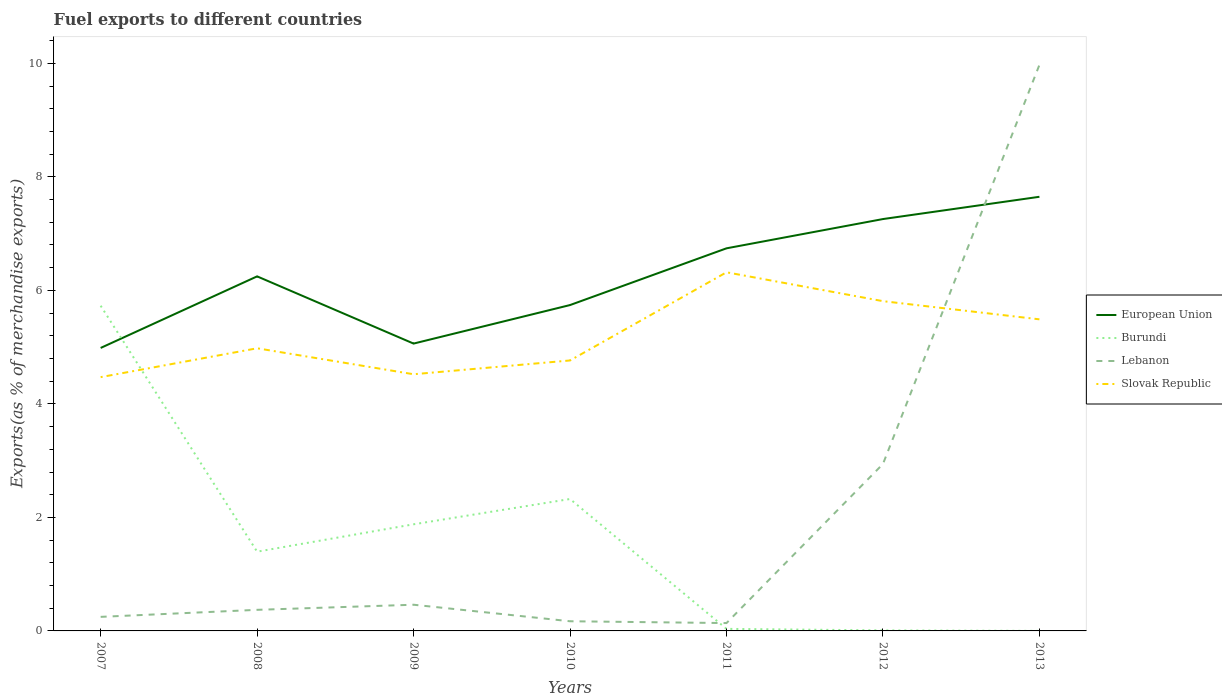Is the number of lines equal to the number of legend labels?
Give a very brief answer. Yes. Across all years, what is the maximum percentage of exports to different countries in Lebanon?
Ensure brevity in your answer.  0.14. What is the total percentage of exports to different countries in Slovak Republic in the graph?
Your answer should be compact. -1.34. What is the difference between the highest and the second highest percentage of exports to different countries in Lebanon?
Give a very brief answer. 9.84. Is the percentage of exports to different countries in Lebanon strictly greater than the percentage of exports to different countries in European Union over the years?
Offer a terse response. No. How many lines are there?
Ensure brevity in your answer.  4. What is the difference between two consecutive major ticks on the Y-axis?
Provide a short and direct response. 2. How are the legend labels stacked?
Offer a terse response. Vertical. What is the title of the graph?
Your response must be concise. Fuel exports to different countries. Does "Maldives" appear as one of the legend labels in the graph?
Keep it short and to the point. No. What is the label or title of the X-axis?
Make the answer very short. Years. What is the label or title of the Y-axis?
Ensure brevity in your answer.  Exports(as % of merchandise exports). What is the Exports(as % of merchandise exports) in European Union in 2007?
Ensure brevity in your answer.  4.99. What is the Exports(as % of merchandise exports) in Burundi in 2007?
Provide a short and direct response. 5.73. What is the Exports(as % of merchandise exports) of Lebanon in 2007?
Make the answer very short. 0.25. What is the Exports(as % of merchandise exports) in Slovak Republic in 2007?
Your answer should be compact. 4.47. What is the Exports(as % of merchandise exports) in European Union in 2008?
Make the answer very short. 6.25. What is the Exports(as % of merchandise exports) of Burundi in 2008?
Offer a terse response. 1.4. What is the Exports(as % of merchandise exports) of Lebanon in 2008?
Your answer should be very brief. 0.37. What is the Exports(as % of merchandise exports) of Slovak Republic in 2008?
Your answer should be compact. 4.98. What is the Exports(as % of merchandise exports) of European Union in 2009?
Your response must be concise. 5.06. What is the Exports(as % of merchandise exports) of Burundi in 2009?
Keep it short and to the point. 1.88. What is the Exports(as % of merchandise exports) in Lebanon in 2009?
Your response must be concise. 0.46. What is the Exports(as % of merchandise exports) in Slovak Republic in 2009?
Give a very brief answer. 4.52. What is the Exports(as % of merchandise exports) in European Union in 2010?
Make the answer very short. 5.74. What is the Exports(as % of merchandise exports) in Burundi in 2010?
Offer a very short reply. 2.32. What is the Exports(as % of merchandise exports) of Lebanon in 2010?
Your answer should be very brief. 0.17. What is the Exports(as % of merchandise exports) in Slovak Republic in 2010?
Provide a succinct answer. 4.77. What is the Exports(as % of merchandise exports) of European Union in 2011?
Provide a short and direct response. 6.74. What is the Exports(as % of merchandise exports) of Burundi in 2011?
Your answer should be very brief. 0.04. What is the Exports(as % of merchandise exports) in Lebanon in 2011?
Offer a very short reply. 0.14. What is the Exports(as % of merchandise exports) of Slovak Republic in 2011?
Offer a terse response. 6.32. What is the Exports(as % of merchandise exports) in European Union in 2012?
Provide a succinct answer. 7.26. What is the Exports(as % of merchandise exports) in Burundi in 2012?
Provide a succinct answer. 0.01. What is the Exports(as % of merchandise exports) in Lebanon in 2012?
Offer a terse response. 2.94. What is the Exports(as % of merchandise exports) in Slovak Republic in 2012?
Your answer should be very brief. 5.81. What is the Exports(as % of merchandise exports) of European Union in 2013?
Offer a very short reply. 7.65. What is the Exports(as % of merchandise exports) of Burundi in 2013?
Ensure brevity in your answer.  0. What is the Exports(as % of merchandise exports) of Lebanon in 2013?
Your answer should be very brief. 9.97. What is the Exports(as % of merchandise exports) in Slovak Republic in 2013?
Offer a terse response. 5.49. Across all years, what is the maximum Exports(as % of merchandise exports) of European Union?
Your answer should be compact. 7.65. Across all years, what is the maximum Exports(as % of merchandise exports) of Burundi?
Your answer should be compact. 5.73. Across all years, what is the maximum Exports(as % of merchandise exports) in Lebanon?
Give a very brief answer. 9.97. Across all years, what is the maximum Exports(as % of merchandise exports) in Slovak Republic?
Your response must be concise. 6.32. Across all years, what is the minimum Exports(as % of merchandise exports) in European Union?
Your answer should be compact. 4.99. Across all years, what is the minimum Exports(as % of merchandise exports) in Burundi?
Keep it short and to the point. 0. Across all years, what is the minimum Exports(as % of merchandise exports) in Lebanon?
Provide a succinct answer. 0.14. Across all years, what is the minimum Exports(as % of merchandise exports) of Slovak Republic?
Make the answer very short. 4.47. What is the total Exports(as % of merchandise exports) of European Union in the graph?
Make the answer very short. 43.68. What is the total Exports(as % of merchandise exports) in Burundi in the graph?
Ensure brevity in your answer.  11.38. What is the total Exports(as % of merchandise exports) in Lebanon in the graph?
Provide a succinct answer. 14.3. What is the total Exports(as % of merchandise exports) of Slovak Republic in the graph?
Keep it short and to the point. 36.36. What is the difference between the Exports(as % of merchandise exports) of European Union in 2007 and that in 2008?
Your response must be concise. -1.26. What is the difference between the Exports(as % of merchandise exports) of Burundi in 2007 and that in 2008?
Provide a short and direct response. 4.33. What is the difference between the Exports(as % of merchandise exports) in Lebanon in 2007 and that in 2008?
Your answer should be compact. -0.12. What is the difference between the Exports(as % of merchandise exports) of Slovak Republic in 2007 and that in 2008?
Ensure brevity in your answer.  -0.51. What is the difference between the Exports(as % of merchandise exports) in European Union in 2007 and that in 2009?
Your answer should be compact. -0.08. What is the difference between the Exports(as % of merchandise exports) of Burundi in 2007 and that in 2009?
Your answer should be compact. 3.85. What is the difference between the Exports(as % of merchandise exports) in Lebanon in 2007 and that in 2009?
Your answer should be compact. -0.21. What is the difference between the Exports(as % of merchandise exports) of Slovak Republic in 2007 and that in 2009?
Your answer should be very brief. -0.05. What is the difference between the Exports(as % of merchandise exports) in European Union in 2007 and that in 2010?
Make the answer very short. -0.76. What is the difference between the Exports(as % of merchandise exports) in Burundi in 2007 and that in 2010?
Ensure brevity in your answer.  3.41. What is the difference between the Exports(as % of merchandise exports) of Lebanon in 2007 and that in 2010?
Give a very brief answer. 0.08. What is the difference between the Exports(as % of merchandise exports) of Slovak Republic in 2007 and that in 2010?
Provide a succinct answer. -0.29. What is the difference between the Exports(as % of merchandise exports) in European Union in 2007 and that in 2011?
Ensure brevity in your answer.  -1.76. What is the difference between the Exports(as % of merchandise exports) of Burundi in 2007 and that in 2011?
Make the answer very short. 5.69. What is the difference between the Exports(as % of merchandise exports) of Lebanon in 2007 and that in 2011?
Give a very brief answer. 0.11. What is the difference between the Exports(as % of merchandise exports) of Slovak Republic in 2007 and that in 2011?
Make the answer very short. -1.85. What is the difference between the Exports(as % of merchandise exports) in European Union in 2007 and that in 2012?
Give a very brief answer. -2.27. What is the difference between the Exports(as % of merchandise exports) of Burundi in 2007 and that in 2012?
Your answer should be compact. 5.72. What is the difference between the Exports(as % of merchandise exports) of Lebanon in 2007 and that in 2012?
Keep it short and to the point. -2.69. What is the difference between the Exports(as % of merchandise exports) in Slovak Republic in 2007 and that in 2012?
Offer a very short reply. -1.34. What is the difference between the Exports(as % of merchandise exports) of European Union in 2007 and that in 2013?
Provide a succinct answer. -2.66. What is the difference between the Exports(as % of merchandise exports) of Burundi in 2007 and that in 2013?
Ensure brevity in your answer.  5.73. What is the difference between the Exports(as % of merchandise exports) of Lebanon in 2007 and that in 2013?
Give a very brief answer. -9.73. What is the difference between the Exports(as % of merchandise exports) of Slovak Republic in 2007 and that in 2013?
Keep it short and to the point. -1.02. What is the difference between the Exports(as % of merchandise exports) of European Union in 2008 and that in 2009?
Offer a terse response. 1.18. What is the difference between the Exports(as % of merchandise exports) in Burundi in 2008 and that in 2009?
Keep it short and to the point. -0.48. What is the difference between the Exports(as % of merchandise exports) of Lebanon in 2008 and that in 2009?
Keep it short and to the point. -0.09. What is the difference between the Exports(as % of merchandise exports) in Slovak Republic in 2008 and that in 2009?
Your answer should be very brief. 0.46. What is the difference between the Exports(as % of merchandise exports) of European Union in 2008 and that in 2010?
Keep it short and to the point. 0.51. What is the difference between the Exports(as % of merchandise exports) in Burundi in 2008 and that in 2010?
Give a very brief answer. -0.93. What is the difference between the Exports(as % of merchandise exports) in Lebanon in 2008 and that in 2010?
Keep it short and to the point. 0.2. What is the difference between the Exports(as % of merchandise exports) of Slovak Republic in 2008 and that in 2010?
Keep it short and to the point. 0.21. What is the difference between the Exports(as % of merchandise exports) of European Union in 2008 and that in 2011?
Offer a very short reply. -0.49. What is the difference between the Exports(as % of merchandise exports) of Burundi in 2008 and that in 2011?
Ensure brevity in your answer.  1.36. What is the difference between the Exports(as % of merchandise exports) of Lebanon in 2008 and that in 2011?
Ensure brevity in your answer.  0.23. What is the difference between the Exports(as % of merchandise exports) in Slovak Republic in 2008 and that in 2011?
Ensure brevity in your answer.  -1.34. What is the difference between the Exports(as % of merchandise exports) in European Union in 2008 and that in 2012?
Offer a terse response. -1.01. What is the difference between the Exports(as % of merchandise exports) in Burundi in 2008 and that in 2012?
Give a very brief answer. 1.39. What is the difference between the Exports(as % of merchandise exports) of Lebanon in 2008 and that in 2012?
Make the answer very short. -2.57. What is the difference between the Exports(as % of merchandise exports) in Slovak Republic in 2008 and that in 2012?
Your answer should be compact. -0.83. What is the difference between the Exports(as % of merchandise exports) of European Union in 2008 and that in 2013?
Provide a succinct answer. -1.4. What is the difference between the Exports(as % of merchandise exports) of Burundi in 2008 and that in 2013?
Give a very brief answer. 1.4. What is the difference between the Exports(as % of merchandise exports) in Lebanon in 2008 and that in 2013?
Offer a terse response. -9.6. What is the difference between the Exports(as % of merchandise exports) of Slovak Republic in 2008 and that in 2013?
Your response must be concise. -0.51. What is the difference between the Exports(as % of merchandise exports) in European Union in 2009 and that in 2010?
Offer a terse response. -0.68. What is the difference between the Exports(as % of merchandise exports) of Burundi in 2009 and that in 2010?
Make the answer very short. -0.45. What is the difference between the Exports(as % of merchandise exports) in Lebanon in 2009 and that in 2010?
Make the answer very short. 0.29. What is the difference between the Exports(as % of merchandise exports) of Slovak Republic in 2009 and that in 2010?
Your answer should be very brief. -0.24. What is the difference between the Exports(as % of merchandise exports) of European Union in 2009 and that in 2011?
Offer a terse response. -1.68. What is the difference between the Exports(as % of merchandise exports) of Burundi in 2009 and that in 2011?
Your answer should be very brief. 1.84. What is the difference between the Exports(as % of merchandise exports) of Lebanon in 2009 and that in 2011?
Offer a terse response. 0.32. What is the difference between the Exports(as % of merchandise exports) of Slovak Republic in 2009 and that in 2011?
Ensure brevity in your answer.  -1.8. What is the difference between the Exports(as % of merchandise exports) of European Union in 2009 and that in 2012?
Your answer should be very brief. -2.19. What is the difference between the Exports(as % of merchandise exports) in Burundi in 2009 and that in 2012?
Provide a succinct answer. 1.87. What is the difference between the Exports(as % of merchandise exports) of Lebanon in 2009 and that in 2012?
Your response must be concise. -2.48. What is the difference between the Exports(as % of merchandise exports) in Slovak Republic in 2009 and that in 2012?
Offer a terse response. -1.29. What is the difference between the Exports(as % of merchandise exports) of European Union in 2009 and that in 2013?
Make the answer very short. -2.59. What is the difference between the Exports(as % of merchandise exports) of Burundi in 2009 and that in 2013?
Offer a very short reply. 1.88. What is the difference between the Exports(as % of merchandise exports) of Lebanon in 2009 and that in 2013?
Offer a very short reply. -9.51. What is the difference between the Exports(as % of merchandise exports) in Slovak Republic in 2009 and that in 2013?
Offer a terse response. -0.97. What is the difference between the Exports(as % of merchandise exports) in European Union in 2010 and that in 2011?
Give a very brief answer. -1. What is the difference between the Exports(as % of merchandise exports) in Burundi in 2010 and that in 2011?
Keep it short and to the point. 2.29. What is the difference between the Exports(as % of merchandise exports) of Lebanon in 2010 and that in 2011?
Ensure brevity in your answer.  0.03. What is the difference between the Exports(as % of merchandise exports) in Slovak Republic in 2010 and that in 2011?
Give a very brief answer. -1.55. What is the difference between the Exports(as % of merchandise exports) of European Union in 2010 and that in 2012?
Your answer should be compact. -1.52. What is the difference between the Exports(as % of merchandise exports) of Burundi in 2010 and that in 2012?
Keep it short and to the point. 2.31. What is the difference between the Exports(as % of merchandise exports) in Lebanon in 2010 and that in 2012?
Your answer should be compact. -2.77. What is the difference between the Exports(as % of merchandise exports) in Slovak Republic in 2010 and that in 2012?
Your answer should be very brief. -1.04. What is the difference between the Exports(as % of merchandise exports) in European Union in 2010 and that in 2013?
Ensure brevity in your answer.  -1.91. What is the difference between the Exports(as % of merchandise exports) of Burundi in 2010 and that in 2013?
Provide a short and direct response. 2.32. What is the difference between the Exports(as % of merchandise exports) of Lebanon in 2010 and that in 2013?
Your response must be concise. -9.8. What is the difference between the Exports(as % of merchandise exports) of Slovak Republic in 2010 and that in 2013?
Keep it short and to the point. -0.72. What is the difference between the Exports(as % of merchandise exports) of European Union in 2011 and that in 2012?
Offer a very short reply. -0.52. What is the difference between the Exports(as % of merchandise exports) in Burundi in 2011 and that in 2012?
Ensure brevity in your answer.  0.03. What is the difference between the Exports(as % of merchandise exports) of Lebanon in 2011 and that in 2012?
Your answer should be compact. -2.8. What is the difference between the Exports(as % of merchandise exports) in Slovak Republic in 2011 and that in 2012?
Keep it short and to the point. 0.51. What is the difference between the Exports(as % of merchandise exports) in European Union in 2011 and that in 2013?
Make the answer very short. -0.91. What is the difference between the Exports(as % of merchandise exports) in Burundi in 2011 and that in 2013?
Provide a succinct answer. 0.04. What is the difference between the Exports(as % of merchandise exports) of Lebanon in 2011 and that in 2013?
Your answer should be compact. -9.84. What is the difference between the Exports(as % of merchandise exports) in Slovak Republic in 2011 and that in 2013?
Provide a short and direct response. 0.83. What is the difference between the Exports(as % of merchandise exports) of European Union in 2012 and that in 2013?
Your response must be concise. -0.39. What is the difference between the Exports(as % of merchandise exports) of Burundi in 2012 and that in 2013?
Ensure brevity in your answer.  0.01. What is the difference between the Exports(as % of merchandise exports) of Lebanon in 2012 and that in 2013?
Offer a terse response. -7.03. What is the difference between the Exports(as % of merchandise exports) in Slovak Republic in 2012 and that in 2013?
Provide a short and direct response. 0.32. What is the difference between the Exports(as % of merchandise exports) in European Union in 2007 and the Exports(as % of merchandise exports) in Burundi in 2008?
Give a very brief answer. 3.59. What is the difference between the Exports(as % of merchandise exports) of European Union in 2007 and the Exports(as % of merchandise exports) of Lebanon in 2008?
Offer a terse response. 4.61. What is the difference between the Exports(as % of merchandise exports) in European Union in 2007 and the Exports(as % of merchandise exports) in Slovak Republic in 2008?
Offer a very short reply. 0.01. What is the difference between the Exports(as % of merchandise exports) in Burundi in 2007 and the Exports(as % of merchandise exports) in Lebanon in 2008?
Your answer should be compact. 5.36. What is the difference between the Exports(as % of merchandise exports) of Burundi in 2007 and the Exports(as % of merchandise exports) of Slovak Republic in 2008?
Make the answer very short. 0.75. What is the difference between the Exports(as % of merchandise exports) of Lebanon in 2007 and the Exports(as % of merchandise exports) of Slovak Republic in 2008?
Your answer should be very brief. -4.73. What is the difference between the Exports(as % of merchandise exports) in European Union in 2007 and the Exports(as % of merchandise exports) in Burundi in 2009?
Make the answer very short. 3.11. What is the difference between the Exports(as % of merchandise exports) of European Union in 2007 and the Exports(as % of merchandise exports) of Lebanon in 2009?
Your response must be concise. 4.52. What is the difference between the Exports(as % of merchandise exports) of European Union in 2007 and the Exports(as % of merchandise exports) of Slovak Republic in 2009?
Make the answer very short. 0.46. What is the difference between the Exports(as % of merchandise exports) of Burundi in 2007 and the Exports(as % of merchandise exports) of Lebanon in 2009?
Your response must be concise. 5.27. What is the difference between the Exports(as % of merchandise exports) in Burundi in 2007 and the Exports(as % of merchandise exports) in Slovak Republic in 2009?
Provide a succinct answer. 1.21. What is the difference between the Exports(as % of merchandise exports) of Lebanon in 2007 and the Exports(as % of merchandise exports) of Slovak Republic in 2009?
Your answer should be compact. -4.27. What is the difference between the Exports(as % of merchandise exports) of European Union in 2007 and the Exports(as % of merchandise exports) of Burundi in 2010?
Your answer should be compact. 2.66. What is the difference between the Exports(as % of merchandise exports) in European Union in 2007 and the Exports(as % of merchandise exports) in Lebanon in 2010?
Provide a succinct answer. 4.82. What is the difference between the Exports(as % of merchandise exports) of European Union in 2007 and the Exports(as % of merchandise exports) of Slovak Republic in 2010?
Your response must be concise. 0.22. What is the difference between the Exports(as % of merchandise exports) in Burundi in 2007 and the Exports(as % of merchandise exports) in Lebanon in 2010?
Make the answer very short. 5.56. What is the difference between the Exports(as % of merchandise exports) of Burundi in 2007 and the Exports(as % of merchandise exports) of Slovak Republic in 2010?
Make the answer very short. 0.96. What is the difference between the Exports(as % of merchandise exports) of Lebanon in 2007 and the Exports(as % of merchandise exports) of Slovak Republic in 2010?
Offer a terse response. -4.52. What is the difference between the Exports(as % of merchandise exports) of European Union in 2007 and the Exports(as % of merchandise exports) of Burundi in 2011?
Offer a very short reply. 4.95. What is the difference between the Exports(as % of merchandise exports) in European Union in 2007 and the Exports(as % of merchandise exports) in Lebanon in 2011?
Offer a terse response. 4.85. What is the difference between the Exports(as % of merchandise exports) in European Union in 2007 and the Exports(as % of merchandise exports) in Slovak Republic in 2011?
Offer a terse response. -1.33. What is the difference between the Exports(as % of merchandise exports) in Burundi in 2007 and the Exports(as % of merchandise exports) in Lebanon in 2011?
Your answer should be compact. 5.59. What is the difference between the Exports(as % of merchandise exports) in Burundi in 2007 and the Exports(as % of merchandise exports) in Slovak Republic in 2011?
Give a very brief answer. -0.59. What is the difference between the Exports(as % of merchandise exports) in Lebanon in 2007 and the Exports(as % of merchandise exports) in Slovak Republic in 2011?
Ensure brevity in your answer.  -6.07. What is the difference between the Exports(as % of merchandise exports) of European Union in 2007 and the Exports(as % of merchandise exports) of Burundi in 2012?
Offer a terse response. 4.98. What is the difference between the Exports(as % of merchandise exports) of European Union in 2007 and the Exports(as % of merchandise exports) of Lebanon in 2012?
Offer a very short reply. 2.04. What is the difference between the Exports(as % of merchandise exports) of European Union in 2007 and the Exports(as % of merchandise exports) of Slovak Republic in 2012?
Your answer should be compact. -0.82. What is the difference between the Exports(as % of merchandise exports) of Burundi in 2007 and the Exports(as % of merchandise exports) of Lebanon in 2012?
Offer a terse response. 2.79. What is the difference between the Exports(as % of merchandise exports) of Burundi in 2007 and the Exports(as % of merchandise exports) of Slovak Republic in 2012?
Your answer should be compact. -0.08. What is the difference between the Exports(as % of merchandise exports) in Lebanon in 2007 and the Exports(as % of merchandise exports) in Slovak Republic in 2012?
Provide a succinct answer. -5.56. What is the difference between the Exports(as % of merchandise exports) in European Union in 2007 and the Exports(as % of merchandise exports) in Burundi in 2013?
Give a very brief answer. 4.99. What is the difference between the Exports(as % of merchandise exports) in European Union in 2007 and the Exports(as % of merchandise exports) in Lebanon in 2013?
Make the answer very short. -4.99. What is the difference between the Exports(as % of merchandise exports) of European Union in 2007 and the Exports(as % of merchandise exports) of Slovak Republic in 2013?
Offer a terse response. -0.5. What is the difference between the Exports(as % of merchandise exports) of Burundi in 2007 and the Exports(as % of merchandise exports) of Lebanon in 2013?
Your answer should be very brief. -4.24. What is the difference between the Exports(as % of merchandise exports) in Burundi in 2007 and the Exports(as % of merchandise exports) in Slovak Republic in 2013?
Offer a terse response. 0.24. What is the difference between the Exports(as % of merchandise exports) of Lebanon in 2007 and the Exports(as % of merchandise exports) of Slovak Republic in 2013?
Provide a succinct answer. -5.24. What is the difference between the Exports(as % of merchandise exports) of European Union in 2008 and the Exports(as % of merchandise exports) of Burundi in 2009?
Offer a very short reply. 4.37. What is the difference between the Exports(as % of merchandise exports) in European Union in 2008 and the Exports(as % of merchandise exports) in Lebanon in 2009?
Your response must be concise. 5.79. What is the difference between the Exports(as % of merchandise exports) of European Union in 2008 and the Exports(as % of merchandise exports) of Slovak Republic in 2009?
Your answer should be compact. 1.72. What is the difference between the Exports(as % of merchandise exports) in Burundi in 2008 and the Exports(as % of merchandise exports) in Lebanon in 2009?
Ensure brevity in your answer.  0.93. What is the difference between the Exports(as % of merchandise exports) in Burundi in 2008 and the Exports(as % of merchandise exports) in Slovak Republic in 2009?
Give a very brief answer. -3.13. What is the difference between the Exports(as % of merchandise exports) in Lebanon in 2008 and the Exports(as % of merchandise exports) in Slovak Republic in 2009?
Provide a short and direct response. -4.15. What is the difference between the Exports(as % of merchandise exports) of European Union in 2008 and the Exports(as % of merchandise exports) of Burundi in 2010?
Your answer should be compact. 3.92. What is the difference between the Exports(as % of merchandise exports) in European Union in 2008 and the Exports(as % of merchandise exports) in Lebanon in 2010?
Offer a terse response. 6.08. What is the difference between the Exports(as % of merchandise exports) of European Union in 2008 and the Exports(as % of merchandise exports) of Slovak Republic in 2010?
Keep it short and to the point. 1.48. What is the difference between the Exports(as % of merchandise exports) in Burundi in 2008 and the Exports(as % of merchandise exports) in Lebanon in 2010?
Keep it short and to the point. 1.23. What is the difference between the Exports(as % of merchandise exports) in Burundi in 2008 and the Exports(as % of merchandise exports) in Slovak Republic in 2010?
Your answer should be compact. -3.37. What is the difference between the Exports(as % of merchandise exports) of Lebanon in 2008 and the Exports(as % of merchandise exports) of Slovak Republic in 2010?
Your answer should be very brief. -4.39. What is the difference between the Exports(as % of merchandise exports) of European Union in 2008 and the Exports(as % of merchandise exports) of Burundi in 2011?
Ensure brevity in your answer.  6.21. What is the difference between the Exports(as % of merchandise exports) in European Union in 2008 and the Exports(as % of merchandise exports) in Lebanon in 2011?
Provide a short and direct response. 6.11. What is the difference between the Exports(as % of merchandise exports) in European Union in 2008 and the Exports(as % of merchandise exports) in Slovak Republic in 2011?
Provide a short and direct response. -0.07. What is the difference between the Exports(as % of merchandise exports) in Burundi in 2008 and the Exports(as % of merchandise exports) in Lebanon in 2011?
Your response must be concise. 1.26. What is the difference between the Exports(as % of merchandise exports) of Burundi in 2008 and the Exports(as % of merchandise exports) of Slovak Republic in 2011?
Offer a terse response. -4.92. What is the difference between the Exports(as % of merchandise exports) in Lebanon in 2008 and the Exports(as % of merchandise exports) in Slovak Republic in 2011?
Keep it short and to the point. -5.95. What is the difference between the Exports(as % of merchandise exports) in European Union in 2008 and the Exports(as % of merchandise exports) in Burundi in 2012?
Give a very brief answer. 6.24. What is the difference between the Exports(as % of merchandise exports) in European Union in 2008 and the Exports(as % of merchandise exports) in Lebanon in 2012?
Your answer should be compact. 3.31. What is the difference between the Exports(as % of merchandise exports) of European Union in 2008 and the Exports(as % of merchandise exports) of Slovak Republic in 2012?
Give a very brief answer. 0.44. What is the difference between the Exports(as % of merchandise exports) of Burundi in 2008 and the Exports(as % of merchandise exports) of Lebanon in 2012?
Make the answer very short. -1.55. What is the difference between the Exports(as % of merchandise exports) in Burundi in 2008 and the Exports(as % of merchandise exports) in Slovak Republic in 2012?
Offer a terse response. -4.41. What is the difference between the Exports(as % of merchandise exports) in Lebanon in 2008 and the Exports(as % of merchandise exports) in Slovak Republic in 2012?
Your response must be concise. -5.44. What is the difference between the Exports(as % of merchandise exports) in European Union in 2008 and the Exports(as % of merchandise exports) in Burundi in 2013?
Offer a terse response. 6.25. What is the difference between the Exports(as % of merchandise exports) in European Union in 2008 and the Exports(as % of merchandise exports) in Lebanon in 2013?
Keep it short and to the point. -3.73. What is the difference between the Exports(as % of merchandise exports) of European Union in 2008 and the Exports(as % of merchandise exports) of Slovak Republic in 2013?
Your response must be concise. 0.76. What is the difference between the Exports(as % of merchandise exports) in Burundi in 2008 and the Exports(as % of merchandise exports) in Lebanon in 2013?
Make the answer very short. -8.58. What is the difference between the Exports(as % of merchandise exports) of Burundi in 2008 and the Exports(as % of merchandise exports) of Slovak Republic in 2013?
Provide a succinct answer. -4.09. What is the difference between the Exports(as % of merchandise exports) in Lebanon in 2008 and the Exports(as % of merchandise exports) in Slovak Republic in 2013?
Ensure brevity in your answer.  -5.12. What is the difference between the Exports(as % of merchandise exports) in European Union in 2009 and the Exports(as % of merchandise exports) in Burundi in 2010?
Provide a succinct answer. 2.74. What is the difference between the Exports(as % of merchandise exports) in European Union in 2009 and the Exports(as % of merchandise exports) in Lebanon in 2010?
Your answer should be very brief. 4.89. What is the difference between the Exports(as % of merchandise exports) of European Union in 2009 and the Exports(as % of merchandise exports) of Slovak Republic in 2010?
Provide a short and direct response. 0.3. What is the difference between the Exports(as % of merchandise exports) in Burundi in 2009 and the Exports(as % of merchandise exports) in Lebanon in 2010?
Your response must be concise. 1.71. What is the difference between the Exports(as % of merchandise exports) in Burundi in 2009 and the Exports(as % of merchandise exports) in Slovak Republic in 2010?
Keep it short and to the point. -2.89. What is the difference between the Exports(as % of merchandise exports) of Lebanon in 2009 and the Exports(as % of merchandise exports) of Slovak Republic in 2010?
Offer a terse response. -4.3. What is the difference between the Exports(as % of merchandise exports) in European Union in 2009 and the Exports(as % of merchandise exports) in Burundi in 2011?
Offer a very short reply. 5.03. What is the difference between the Exports(as % of merchandise exports) of European Union in 2009 and the Exports(as % of merchandise exports) of Lebanon in 2011?
Your answer should be compact. 4.92. What is the difference between the Exports(as % of merchandise exports) in European Union in 2009 and the Exports(as % of merchandise exports) in Slovak Republic in 2011?
Your response must be concise. -1.26. What is the difference between the Exports(as % of merchandise exports) in Burundi in 2009 and the Exports(as % of merchandise exports) in Lebanon in 2011?
Provide a succinct answer. 1.74. What is the difference between the Exports(as % of merchandise exports) of Burundi in 2009 and the Exports(as % of merchandise exports) of Slovak Republic in 2011?
Offer a very short reply. -4.44. What is the difference between the Exports(as % of merchandise exports) in Lebanon in 2009 and the Exports(as % of merchandise exports) in Slovak Republic in 2011?
Keep it short and to the point. -5.86. What is the difference between the Exports(as % of merchandise exports) in European Union in 2009 and the Exports(as % of merchandise exports) in Burundi in 2012?
Give a very brief answer. 5.05. What is the difference between the Exports(as % of merchandise exports) in European Union in 2009 and the Exports(as % of merchandise exports) in Lebanon in 2012?
Give a very brief answer. 2.12. What is the difference between the Exports(as % of merchandise exports) of European Union in 2009 and the Exports(as % of merchandise exports) of Slovak Republic in 2012?
Offer a very short reply. -0.75. What is the difference between the Exports(as % of merchandise exports) in Burundi in 2009 and the Exports(as % of merchandise exports) in Lebanon in 2012?
Provide a short and direct response. -1.06. What is the difference between the Exports(as % of merchandise exports) in Burundi in 2009 and the Exports(as % of merchandise exports) in Slovak Republic in 2012?
Give a very brief answer. -3.93. What is the difference between the Exports(as % of merchandise exports) of Lebanon in 2009 and the Exports(as % of merchandise exports) of Slovak Republic in 2012?
Your response must be concise. -5.35. What is the difference between the Exports(as % of merchandise exports) in European Union in 2009 and the Exports(as % of merchandise exports) in Burundi in 2013?
Give a very brief answer. 5.06. What is the difference between the Exports(as % of merchandise exports) in European Union in 2009 and the Exports(as % of merchandise exports) in Lebanon in 2013?
Your answer should be very brief. -4.91. What is the difference between the Exports(as % of merchandise exports) in European Union in 2009 and the Exports(as % of merchandise exports) in Slovak Republic in 2013?
Your answer should be very brief. -0.43. What is the difference between the Exports(as % of merchandise exports) in Burundi in 2009 and the Exports(as % of merchandise exports) in Lebanon in 2013?
Offer a terse response. -8.09. What is the difference between the Exports(as % of merchandise exports) in Burundi in 2009 and the Exports(as % of merchandise exports) in Slovak Republic in 2013?
Your answer should be very brief. -3.61. What is the difference between the Exports(as % of merchandise exports) in Lebanon in 2009 and the Exports(as % of merchandise exports) in Slovak Republic in 2013?
Your answer should be very brief. -5.03. What is the difference between the Exports(as % of merchandise exports) of European Union in 2010 and the Exports(as % of merchandise exports) of Burundi in 2011?
Make the answer very short. 5.71. What is the difference between the Exports(as % of merchandise exports) of European Union in 2010 and the Exports(as % of merchandise exports) of Lebanon in 2011?
Keep it short and to the point. 5.6. What is the difference between the Exports(as % of merchandise exports) of European Union in 2010 and the Exports(as % of merchandise exports) of Slovak Republic in 2011?
Make the answer very short. -0.58. What is the difference between the Exports(as % of merchandise exports) of Burundi in 2010 and the Exports(as % of merchandise exports) of Lebanon in 2011?
Make the answer very short. 2.19. What is the difference between the Exports(as % of merchandise exports) in Burundi in 2010 and the Exports(as % of merchandise exports) in Slovak Republic in 2011?
Your answer should be compact. -3.99. What is the difference between the Exports(as % of merchandise exports) of Lebanon in 2010 and the Exports(as % of merchandise exports) of Slovak Republic in 2011?
Provide a short and direct response. -6.15. What is the difference between the Exports(as % of merchandise exports) in European Union in 2010 and the Exports(as % of merchandise exports) in Burundi in 2012?
Offer a very short reply. 5.73. What is the difference between the Exports(as % of merchandise exports) in European Union in 2010 and the Exports(as % of merchandise exports) in Lebanon in 2012?
Offer a terse response. 2.8. What is the difference between the Exports(as % of merchandise exports) of European Union in 2010 and the Exports(as % of merchandise exports) of Slovak Republic in 2012?
Ensure brevity in your answer.  -0.07. What is the difference between the Exports(as % of merchandise exports) of Burundi in 2010 and the Exports(as % of merchandise exports) of Lebanon in 2012?
Your answer should be compact. -0.62. What is the difference between the Exports(as % of merchandise exports) of Burundi in 2010 and the Exports(as % of merchandise exports) of Slovak Republic in 2012?
Make the answer very short. -3.49. What is the difference between the Exports(as % of merchandise exports) in Lebanon in 2010 and the Exports(as % of merchandise exports) in Slovak Republic in 2012?
Offer a very short reply. -5.64. What is the difference between the Exports(as % of merchandise exports) of European Union in 2010 and the Exports(as % of merchandise exports) of Burundi in 2013?
Your answer should be compact. 5.74. What is the difference between the Exports(as % of merchandise exports) of European Union in 2010 and the Exports(as % of merchandise exports) of Lebanon in 2013?
Provide a short and direct response. -4.23. What is the difference between the Exports(as % of merchandise exports) of European Union in 2010 and the Exports(as % of merchandise exports) of Slovak Republic in 2013?
Offer a terse response. 0.25. What is the difference between the Exports(as % of merchandise exports) of Burundi in 2010 and the Exports(as % of merchandise exports) of Lebanon in 2013?
Provide a short and direct response. -7.65. What is the difference between the Exports(as % of merchandise exports) of Burundi in 2010 and the Exports(as % of merchandise exports) of Slovak Republic in 2013?
Your response must be concise. -3.17. What is the difference between the Exports(as % of merchandise exports) of Lebanon in 2010 and the Exports(as % of merchandise exports) of Slovak Republic in 2013?
Make the answer very short. -5.32. What is the difference between the Exports(as % of merchandise exports) in European Union in 2011 and the Exports(as % of merchandise exports) in Burundi in 2012?
Your response must be concise. 6.73. What is the difference between the Exports(as % of merchandise exports) of European Union in 2011 and the Exports(as % of merchandise exports) of Lebanon in 2012?
Your answer should be compact. 3.8. What is the difference between the Exports(as % of merchandise exports) of European Union in 2011 and the Exports(as % of merchandise exports) of Slovak Republic in 2012?
Ensure brevity in your answer.  0.93. What is the difference between the Exports(as % of merchandise exports) in Burundi in 2011 and the Exports(as % of merchandise exports) in Lebanon in 2012?
Your response must be concise. -2.91. What is the difference between the Exports(as % of merchandise exports) of Burundi in 2011 and the Exports(as % of merchandise exports) of Slovak Republic in 2012?
Offer a very short reply. -5.77. What is the difference between the Exports(as % of merchandise exports) of Lebanon in 2011 and the Exports(as % of merchandise exports) of Slovak Republic in 2012?
Your response must be concise. -5.67. What is the difference between the Exports(as % of merchandise exports) of European Union in 2011 and the Exports(as % of merchandise exports) of Burundi in 2013?
Your answer should be compact. 6.74. What is the difference between the Exports(as % of merchandise exports) in European Union in 2011 and the Exports(as % of merchandise exports) in Lebanon in 2013?
Provide a short and direct response. -3.23. What is the difference between the Exports(as % of merchandise exports) in European Union in 2011 and the Exports(as % of merchandise exports) in Slovak Republic in 2013?
Ensure brevity in your answer.  1.25. What is the difference between the Exports(as % of merchandise exports) in Burundi in 2011 and the Exports(as % of merchandise exports) in Lebanon in 2013?
Give a very brief answer. -9.94. What is the difference between the Exports(as % of merchandise exports) in Burundi in 2011 and the Exports(as % of merchandise exports) in Slovak Republic in 2013?
Your answer should be compact. -5.45. What is the difference between the Exports(as % of merchandise exports) of Lebanon in 2011 and the Exports(as % of merchandise exports) of Slovak Republic in 2013?
Offer a terse response. -5.35. What is the difference between the Exports(as % of merchandise exports) in European Union in 2012 and the Exports(as % of merchandise exports) in Burundi in 2013?
Ensure brevity in your answer.  7.26. What is the difference between the Exports(as % of merchandise exports) in European Union in 2012 and the Exports(as % of merchandise exports) in Lebanon in 2013?
Your answer should be compact. -2.72. What is the difference between the Exports(as % of merchandise exports) in European Union in 2012 and the Exports(as % of merchandise exports) in Slovak Republic in 2013?
Give a very brief answer. 1.77. What is the difference between the Exports(as % of merchandise exports) in Burundi in 2012 and the Exports(as % of merchandise exports) in Lebanon in 2013?
Your response must be concise. -9.96. What is the difference between the Exports(as % of merchandise exports) in Burundi in 2012 and the Exports(as % of merchandise exports) in Slovak Republic in 2013?
Give a very brief answer. -5.48. What is the difference between the Exports(as % of merchandise exports) of Lebanon in 2012 and the Exports(as % of merchandise exports) of Slovak Republic in 2013?
Offer a very short reply. -2.55. What is the average Exports(as % of merchandise exports) in European Union per year?
Provide a short and direct response. 6.24. What is the average Exports(as % of merchandise exports) in Burundi per year?
Make the answer very short. 1.62. What is the average Exports(as % of merchandise exports) of Lebanon per year?
Ensure brevity in your answer.  2.04. What is the average Exports(as % of merchandise exports) of Slovak Republic per year?
Offer a terse response. 5.19. In the year 2007, what is the difference between the Exports(as % of merchandise exports) in European Union and Exports(as % of merchandise exports) in Burundi?
Provide a short and direct response. -0.74. In the year 2007, what is the difference between the Exports(as % of merchandise exports) in European Union and Exports(as % of merchandise exports) in Lebanon?
Your answer should be very brief. 4.74. In the year 2007, what is the difference between the Exports(as % of merchandise exports) of European Union and Exports(as % of merchandise exports) of Slovak Republic?
Ensure brevity in your answer.  0.51. In the year 2007, what is the difference between the Exports(as % of merchandise exports) in Burundi and Exports(as % of merchandise exports) in Lebanon?
Give a very brief answer. 5.48. In the year 2007, what is the difference between the Exports(as % of merchandise exports) in Burundi and Exports(as % of merchandise exports) in Slovak Republic?
Offer a terse response. 1.26. In the year 2007, what is the difference between the Exports(as % of merchandise exports) in Lebanon and Exports(as % of merchandise exports) in Slovak Republic?
Ensure brevity in your answer.  -4.22. In the year 2008, what is the difference between the Exports(as % of merchandise exports) in European Union and Exports(as % of merchandise exports) in Burundi?
Give a very brief answer. 4.85. In the year 2008, what is the difference between the Exports(as % of merchandise exports) of European Union and Exports(as % of merchandise exports) of Lebanon?
Keep it short and to the point. 5.88. In the year 2008, what is the difference between the Exports(as % of merchandise exports) in European Union and Exports(as % of merchandise exports) in Slovak Republic?
Keep it short and to the point. 1.27. In the year 2008, what is the difference between the Exports(as % of merchandise exports) in Burundi and Exports(as % of merchandise exports) in Lebanon?
Your answer should be very brief. 1.02. In the year 2008, what is the difference between the Exports(as % of merchandise exports) in Burundi and Exports(as % of merchandise exports) in Slovak Republic?
Your response must be concise. -3.58. In the year 2008, what is the difference between the Exports(as % of merchandise exports) of Lebanon and Exports(as % of merchandise exports) of Slovak Republic?
Keep it short and to the point. -4.61. In the year 2009, what is the difference between the Exports(as % of merchandise exports) in European Union and Exports(as % of merchandise exports) in Burundi?
Provide a succinct answer. 3.18. In the year 2009, what is the difference between the Exports(as % of merchandise exports) of European Union and Exports(as % of merchandise exports) of Lebanon?
Offer a terse response. 4.6. In the year 2009, what is the difference between the Exports(as % of merchandise exports) of European Union and Exports(as % of merchandise exports) of Slovak Republic?
Ensure brevity in your answer.  0.54. In the year 2009, what is the difference between the Exports(as % of merchandise exports) of Burundi and Exports(as % of merchandise exports) of Lebanon?
Your response must be concise. 1.42. In the year 2009, what is the difference between the Exports(as % of merchandise exports) in Burundi and Exports(as % of merchandise exports) in Slovak Republic?
Ensure brevity in your answer.  -2.64. In the year 2009, what is the difference between the Exports(as % of merchandise exports) in Lebanon and Exports(as % of merchandise exports) in Slovak Republic?
Offer a very short reply. -4.06. In the year 2010, what is the difference between the Exports(as % of merchandise exports) in European Union and Exports(as % of merchandise exports) in Burundi?
Offer a terse response. 3.42. In the year 2010, what is the difference between the Exports(as % of merchandise exports) of European Union and Exports(as % of merchandise exports) of Lebanon?
Make the answer very short. 5.57. In the year 2010, what is the difference between the Exports(as % of merchandise exports) of European Union and Exports(as % of merchandise exports) of Slovak Republic?
Offer a very short reply. 0.98. In the year 2010, what is the difference between the Exports(as % of merchandise exports) of Burundi and Exports(as % of merchandise exports) of Lebanon?
Provide a succinct answer. 2.15. In the year 2010, what is the difference between the Exports(as % of merchandise exports) in Burundi and Exports(as % of merchandise exports) in Slovak Republic?
Your response must be concise. -2.44. In the year 2010, what is the difference between the Exports(as % of merchandise exports) in Lebanon and Exports(as % of merchandise exports) in Slovak Republic?
Ensure brevity in your answer.  -4.59. In the year 2011, what is the difference between the Exports(as % of merchandise exports) of European Union and Exports(as % of merchandise exports) of Burundi?
Your response must be concise. 6.7. In the year 2011, what is the difference between the Exports(as % of merchandise exports) of European Union and Exports(as % of merchandise exports) of Lebanon?
Your answer should be very brief. 6.6. In the year 2011, what is the difference between the Exports(as % of merchandise exports) in European Union and Exports(as % of merchandise exports) in Slovak Republic?
Your response must be concise. 0.42. In the year 2011, what is the difference between the Exports(as % of merchandise exports) of Burundi and Exports(as % of merchandise exports) of Lebanon?
Provide a succinct answer. -0.1. In the year 2011, what is the difference between the Exports(as % of merchandise exports) of Burundi and Exports(as % of merchandise exports) of Slovak Republic?
Your answer should be compact. -6.28. In the year 2011, what is the difference between the Exports(as % of merchandise exports) of Lebanon and Exports(as % of merchandise exports) of Slovak Republic?
Provide a succinct answer. -6.18. In the year 2012, what is the difference between the Exports(as % of merchandise exports) in European Union and Exports(as % of merchandise exports) in Burundi?
Offer a terse response. 7.25. In the year 2012, what is the difference between the Exports(as % of merchandise exports) of European Union and Exports(as % of merchandise exports) of Lebanon?
Give a very brief answer. 4.32. In the year 2012, what is the difference between the Exports(as % of merchandise exports) of European Union and Exports(as % of merchandise exports) of Slovak Republic?
Give a very brief answer. 1.45. In the year 2012, what is the difference between the Exports(as % of merchandise exports) of Burundi and Exports(as % of merchandise exports) of Lebanon?
Your response must be concise. -2.93. In the year 2012, what is the difference between the Exports(as % of merchandise exports) of Burundi and Exports(as % of merchandise exports) of Slovak Republic?
Keep it short and to the point. -5.8. In the year 2012, what is the difference between the Exports(as % of merchandise exports) of Lebanon and Exports(as % of merchandise exports) of Slovak Republic?
Your answer should be very brief. -2.87. In the year 2013, what is the difference between the Exports(as % of merchandise exports) in European Union and Exports(as % of merchandise exports) in Burundi?
Offer a terse response. 7.65. In the year 2013, what is the difference between the Exports(as % of merchandise exports) in European Union and Exports(as % of merchandise exports) in Lebanon?
Make the answer very short. -2.32. In the year 2013, what is the difference between the Exports(as % of merchandise exports) in European Union and Exports(as % of merchandise exports) in Slovak Republic?
Offer a very short reply. 2.16. In the year 2013, what is the difference between the Exports(as % of merchandise exports) of Burundi and Exports(as % of merchandise exports) of Lebanon?
Keep it short and to the point. -9.97. In the year 2013, what is the difference between the Exports(as % of merchandise exports) in Burundi and Exports(as % of merchandise exports) in Slovak Republic?
Offer a terse response. -5.49. In the year 2013, what is the difference between the Exports(as % of merchandise exports) in Lebanon and Exports(as % of merchandise exports) in Slovak Republic?
Give a very brief answer. 4.48. What is the ratio of the Exports(as % of merchandise exports) of European Union in 2007 to that in 2008?
Make the answer very short. 0.8. What is the ratio of the Exports(as % of merchandise exports) in Burundi in 2007 to that in 2008?
Make the answer very short. 4.1. What is the ratio of the Exports(as % of merchandise exports) in Lebanon in 2007 to that in 2008?
Give a very brief answer. 0.67. What is the ratio of the Exports(as % of merchandise exports) of Slovak Republic in 2007 to that in 2008?
Keep it short and to the point. 0.9. What is the ratio of the Exports(as % of merchandise exports) in European Union in 2007 to that in 2009?
Offer a terse response. 0.98. What is the ratio of the Exports(as % of merchandise exports) of Burundi in 2007 to that in 2009?
Your answer should be very brief. 3.05. What is the ratio of the Exports(as % of merchandise exports) in Lebanon in 2007 to that in 2009?
Offer a very short reply. 0.54. What is the ratio of the Exports(as % of merchandise exports) of Slovak Republic in 2007 to that in 2009?
Give a very brief answer. 0.99. What is the ratio of the Exports(as % of merchandise exports) of European Union in 2007 to that in 2010?
Provide a short and direct response. 0.87. What is the ratio of the Exports(as % of merchandise exports) in Burundi in 2007 to that in 2010?
Ensure brevity in your answer.  2.47. What is the ratio of the Exports(as % of merchandise exports) of Lebanon in 2007 to that in 2010?
Your answer should be compact. 1.45. What is the ratio of the Exports(as % of merchandise exports) of Slovak Republic in 2007 to that in 2010?
Give a very brief answer. 0.94. What is the ratio of the Exports(as % of merchandise exports) of European Union in 2007 to that in 2011?
Make the answer very short. 0.74. What is the ratio of the Exports(as % of merchandise exports) of Burundi in 2007 to that in 2011?
Your response must be concise. 158.2. What is the ratio of the Exports(as % of merchandise exports) of Lebanon in 2007 to that in 2011?
Offer a terse response. 1.79. What is the ratio of the Exports(as % of merchandise exports) of Slovak Republic in 2007 to that in 2011?
Keep it short and to the point. 0.71. What is the ratio of the Exports(as % of merchandise exports) of European Union in 2007 to that in 2012?
Your answer should be compact. 0.69. What is the ratio of the Exports(as % of merchandise exports) in Burundi in 2007 to that in 2012?
Ensure brevity in your answer.  612.09. What is the ratio of the Exports(as % of merchandise exports) in Lebanon in 2007 to that in 2012?
Give a very brief answer. 0.08. What is the ratio of the Exports(as % of merchandise exports) of Slovak Republic in 2007 to that in 2012?
Provide a succinct answer. 0.77. What is the ratio of the Exports(as % of merchandise exports) in European Union in 2007 to that in 2013?
Provide a succinct answer. 0.65. What is the ratio of the Exports(as % of merchandise exports) in Burundi in 2007 to that in 2013?
Offer a very short reply. 1.22e+04. What is the ratio of the Exports(as % of merchandise exports) of Lebanon in 2007 to that in 2013?
Give a very brief answer. 0.02. What is the ratio of the Exports(as % of merchandise exports) of Slovak Republic in 2007 to that in 2013?
Provide a short and direct response. 0.81. What is the ratio of the Exports(as % of merchandise exports) of European Union in 2008 to that in 2009?
Ensure brevity in your answer.  1.23. What is the ratio of the Exports(as % of merchandise exports) of Burundi in 2008 to that in 2009?
Offer a terse response. 0.74. What is the ratio of the Exports(as % of merchandise exports) in Lebanon in 2008 to that in 2009?
Your answer should be compact. 0.81. What is the ratio of the Exports(as % of merchandise exports) of Slovak Republic in 2008 to that in 2009?
Make the answer very short. 1.1. What is the ratio of the Exports(as % of merchandise exports) in European Union in 2008 to that in 2010?
Give a very brief answer. 1.09. What is the ratio of the Exports(as % of merchandise exports) of Burundi in 2008 to that in 2010?
Keep it short and to the point. 0.6. What is the ratio of the Exports(as % of merchandise exports) of Lebanon in 2008 to that in 2010?
Ensure brevity in your answer.  2.18. What is the ratio of the Exports(as % of merchandise exports) of Slovak Republic in 2008 to that in 2010?
Provide a short and direct response. 1.04. What is the ratio of the Exports(as % of merchandise exports) of European Union in 2008 to that in 2011?
Offer a very short reply. 0.93. What is the ratio of the Exports(as % of merchandise exports) in Burundi in 2008 to that in 2011?
Your answer should be very brief. 38.55. What is the ratio of the Exports(as % of merchandise exports) of Lebanon in 2008 to that in 2011?
Keep it short and to the point. 2.69. What is the ratio of the Exports(as % of merchandise exports) in Slovak Republic in 2008 to that in 2011?
Offer a very short reply. 0.79. What is the ratio of the Exports(as % of merchandise exports) in European Union in 2008 to that in 2012?
Keep it short and to the point. 0.86. What is the ratio of the Exports(as % of merchandise exports) in Burundi in 2008 to that in 2012?
Offer a terse response. 149.17. What is the ratio of the Exports(as % of merchandise exports) in Lebanon in 2008 to that in 2012?
Keep it short and to the point. 0.13. What is the ratio of the Exports(as % of merchandise exports) in Slovak Republic in 2008 to that in 2012?
Provide a succinct answer. 0.86. What is the ratio of the Exports(as % of merchandise exports) of European Union in 2008 to that in 2013?
Your answer should be very brief. 0.82. What is the ratio of the Exports(as % of merchandise exports) in Burundi in 2008 to that in 2013?
Your answer should be compact. 2984.58. What is the ratio of the Exports(as % of merchandise exports) of Lebanon in 2008 to that in 2013?
Ensure brevity in your answer.  0.04. What is the ratio of the Exports(as % of merchandise exports) in Slovak Republic in 2008 to that in 2013?
Offer a terse response. 0.91. What is the ratio of the Exports(as % of merchandise exports) of European Union in 2009 to that in 2010?
Your response must be concise. 0.88. What is the ratio of the Exports(as % of merchandise exports) of Burundi in 2009 to that in 2010?
Provide a short and direct response. 0.81. What is the ratio of the Exports(as % of merchandise exports) of Lebanon in 2009 to that in 2010?
Your answer should be compact. 2.71. What is the ratio of the Exports(as % of merchandise exports) of Slovak Republic in 2009 to that in 2010?
Make the answer very short. 0.95. What is the ratio of the Exports(as % of merchandise exports) in European Union in 2009 to that in 2011?
Offer a terse response. 0.75. What is the ratio of the Exports(as % of merchandise exports) of Burundi in 2009 to that in 2011?
Provide a short and direct response. 51.87. What is the ratio of the Exports(as % of merchandise exports) in Lebanon in 2009 to that in 2011?
Offer a very short reply. 3.34. What is the ratio of the Exports(as % of merchandise exports) in Slovak Republic in 2009 to that in 2011?
Offer a very short reply. 0.72. What is the ratio of the Exports(as % of merchandise exports) in European Union in 2009 to that in 2012?
Provide a succinct answer. 0.7. What is the ratio of the Exports(as % of merchandise exports) of Burundi in 2009 to that in 2012?
Ensure brevity in your answer.  200.68. What is the ratio of the Exports(as % of merchandise exports) of Lebanon in 2009 to that in 2012?
Provide a succinct answer. 0.16. What is the ratio of the Exports(as % of merchandise exports) in Slovak Republic in 2009 to that in 2012?
Offer a terse response. 0.78. What is the ratio of the Exports(as % of merchandise exports) in European Union in 2009 to that in 2013?
Provide a short and direct response. 0.66. What is the ratio of the Exports(as % of merchandise exports) of Burundi in 2009 to that in 2013?
Keep it short and to the point. 4015.3. What is the ratio of the Exports(as % of merchandise exports) of Lebanon in 2009 to that in 2013?
Give a very brief answer. 0.05. What is the ratio of the Exports(as % of merchandise exports) in Slovak Republic in 2009 to that in 2013?
Ensure brevity in your answer.  0.82. What is the ratio of the Exports(as % of merchandise exports) of European Union in 2010 to that in 2011?
Offer a terse response. 0.85. What is the ratio of the Exports(as % of merchandise exports) of Burundi in 2010 to that in 2011?
Give a very brief answer. 64.18. What is the ratio of the Exports(as % of merchandise exports) in Lebanon in 2010 to that in 2011?
Your answer should be very brief. 1.23. What is the ratio of the Exports(as % of merchandise exports) of Slovak Republic in 2010 to that in 2011?
Provide a succinct answer. 0.75. What is the ratio of the Exports(as % of merchandise exports) of European Union in 2010 to that in 2012?
Provide a succinct answer. 0.79. What is the ratio of the Exports(as % of merchandise exports) in Burundi in 2010 to that in 2012?
Give a very brief answer. 248.29. What is the ratio of the Exports(as % of merchandise exports) of Lebanon in 2010 to that in 2012?
Your answer should be compact. 0.06. What is the ratio of the Exports(as % of merchandise exports) of Slovak Republic in 2010 to that in 2012?
Provide a short and direct response. 0.82. What is the ratio of the Exports(as % of merchandise exports) in European Union in 2010 to that in 2013?
Your answer should be compact. 0.75. What is the ratio of the Exports(as % of merchandise exports) of Burundi in 2010 to that in 2013?
Ensure brevity in your answer.  4967.93. What is the ratio of the Exports(as % of merchandise exports) of Lebanon in 2010 to that in 2013?
Give a very brief answer. 0.02. What is the ratio of the Exports(as % of merchandise exports) of Slovak Republic in 2010 to that in 2013?
Your answer should be very brief. 0.87. What is the ratio of the Exports(as % of merchandise exports) in European Union in 2011 to that in 2012?
Your answer should be compact. 0.93. What is the ratio of the Exports(as % of merchandise exports) of Burundi in 2011 to that in 2012?
Give a very brief answer. 3.87. What is the ratio of the Exports(as % of merchandise exports) in Lebanon in 2011 to that in 2012?
Offer a very short reply. 0.05. What is the ratio of the Exports(as % of merchandise exports) of Slovak Republic in 2011 to that in 2012?
Make the answer very short. 1.09. What is the ratio of the Exports(as % of merchandise exports) of European Union in 2011 to that in 2013?
Provide a succinct answer. 0.88. What is the ratio of the Exports(as % of merchandise exports) of Burundi in 2011 to that in 2013?
Your answer should be compact. 77.41. What is the ratio of the Exports(as % of merchandise exports) in Lebanon in 2011 to that in 2013?
Give a very brief answer. 0.01. What is the ratio of the Exports(as % of merchandise exports) of Slovak Republic in 2011 to that in 2013?
Offer a very short reply. 1.15. What is the ratio of the Exports(as % of merchandise exports) of European Union in 2012 to that in 2013?
Give a very brief answer. 0.95. What is the ratio of the Exports(as % of merchandise exports) in Burundi in 2012 to that in 2013?
Provide a succinct answer. 20.01. What is the ratio of the Exports(as % of merchandise exports) in Lebanon in 2012 to that in 2013?
Make the answer very short. 0.29. What is the ratio of the Exports(as % of merchandise exports) of Slovak Republic in 2012 to that in 2013?
Make the answer very short. 1.06. What is the difference between the highest and the second highest Exports(as % of merchandise exports) of European Union?
Your response must be concise. 0.39. What is the difference between the highest and the second highest Exports(as % of merchandise exports) in Burundi?
Your answer should be very brief. 3.41. What is the difference between the highest and the second highest Exports(as % of merchandise exports) in Lebanon?
Offer a very short reply. 7.03. What is the difference between the highest and the second highest Exports(as % of merchandise exports) of Slovak Republic?
Give a very brief answer. 0.51. What is the difference between the highest and the lowest Exports(as % of merchandise exports) in European Union?
Offer a very short reply. 2.66. What is the difference between the highest and the lowest Exports(as % of merchandise exports) of Burundi?
Offer a very short reply. 5.73. What is the difference between the highest and the lowest Exports(as % of merchandise exports) of Lebanon?
Ensure brevity in your answer.  9.84. What is the difference between the highest and the lowest Exports(as % of merchandise exports) of Slovak Republic?
Offer a very short reply. 1.85. 